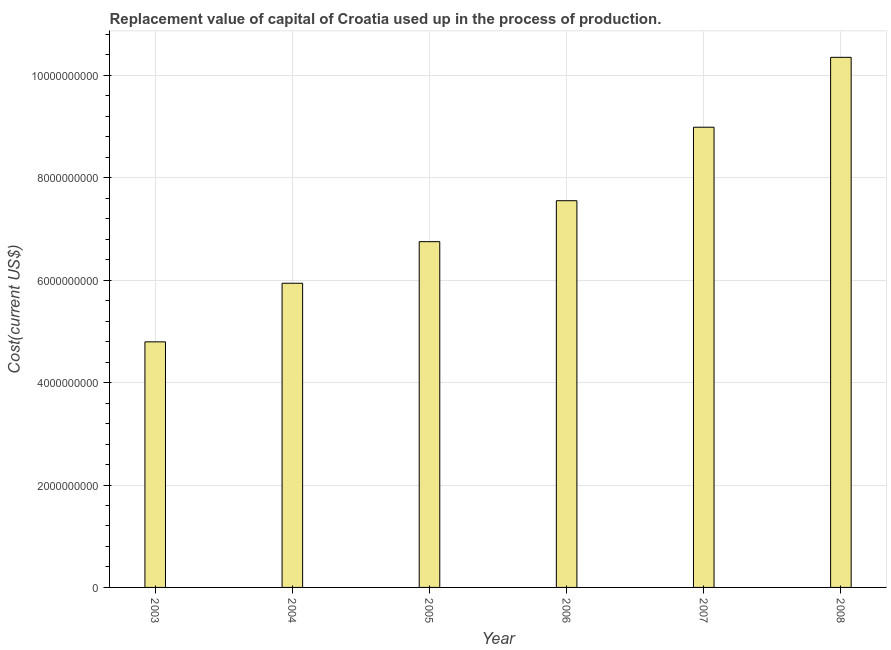Does the graph contain any zero values?
Make the answer very short. No. Does the graph contain grids?
Offer a terse response. Yes. What is the title of the graph?
Give a very brief answer. Replacement value of capital of Croatia used up in the process of production. What is the label or title of the X-axis?
Give a very brief answer. Year. What is the label or title of the Y-axis?
Offer a very short reply. Cost(current US$). What is the consumption of fixed capital in 2006?
Offer a terse response. 7.55e+09. Across all years, what is the maximum consumption of fixed capital?
Provide a succinct answer. 1.04e+1. Across all years, what is the minimum consumption of fixed capital?
Your answer should be very brief. 4.80e+09. In which year was the consumption of fixed capital maximum?
Give a very brief answer. 2008. In which year was the consumption of fixed capital minimum?
Provide a succinct answer. 2003. What is the sum of the consumption of fixed capital?
Give a very brief answer. 4.44e+1. What is the difference between the consumption of fixed capital in 2005 and 2008?
Provide a succinct answer. -3.60e+09. What is the average consumption of fixed capital per year?
Keep it short and to the point. 7.40e+09. What is the median consumption of fixed capital?
Provide a succinct answer. 7.15e+09. Do a majority of the years between 2006 and 2007 (inclusive) have consumption of fixed capital greater than 7200000000 US$?
Offer a terse response. Yes. What is the ratio of the consumption of fixed capital in 2007 to that in 2008?
Give a very brief answer. 0.87. Is the consumption of fixed capital in 2005 less than that in 2008?
Offer a terse response. Yes. Is the difference between the consumption of fixed capital in 2005 and 2007 greater than the difference between any two years?
Offer a terse response. No. What is the difference between the highest and the second highest consumption of fixed capital?
Offer a terse response. 1.37e+09. Is the sum of the consumption of fixed capital in 2006 and 2008 greater than the maximum consumption of fixed capital across all years?
Offer a terse response. Yes. What is the difference between the highest and the lowest consumption of fixed capital?
Your answer should be very brief. 5.56e+09. In how many years, is the consumption of fixed capital greater than the average consumption of fixed capital taken over all years?
Provide a short and direct response. 3. How many bars are there?
Keep it short and to the point. 6. Are all the bars in the graph horizontal?
Ensure brevity in your answer.  No. How many years are there in the graph?
Provide a short and direct response. 6. Are the values on the major ticks of Y-axis written in scientific E-notation?
Provide a short and direct response. No. What is the Cost(current US$) in 2003?
Give a very brief answer. 4.80e+09. What is the Cost(current US$) of 2004?
Offer a very short reply. 5.94e+09. What is the Cost(current US$) in 2005?
Offer a terse response. 6.75e+09. What is the Cost(current US$) in 2006?
Your response must be concise. 7.55e+09. What is the Cost(current US$) in 2007?
Offer a terse response. 8.99e+09. What is the Cost(current US$) in 2008?
Keep it short and to the point. 1.04e+1. What is the difference between the Cost(current US$) in 2003 and 2004?
Your answer should be compact. -1.14e+09. What is the difference between the Cost(current US$) in 2003 and 2005?
Your answer should be very brief. -1.96e+09. What is the difference between the Cost(current US$) in 2003 and 2006?
Provide a succinct answer. -2.76e+09. What is the difference between the Cost(current US$) in 2003 and 2007?
Your response must be concise. -4.19e+09. What is the difference between the Cost(current US$) in 2003 and 2008?
Provide a short and direct response. -5.56e+09. What is the difference between the Cost(current US$) in 2004 and 2005?
Make the answer very short. -8.12e+08. What is the difference between the Cost(current US$) in 2004 and 2006?
Your answer should be very brief. -1.61e+09. What is the difference between the Cost(current US$) in 2004 and 2007?
Make the answer very short. -3.05e+09. What is the difference between the Cost(current US$) in 2004 and 2008?
Your answer should be compact. -4.41e+09. What is the difference between the Cost(current US$) in 2005 and 2006?
Your response must be concise. -8.00e+08. What is the difference between the Cost(current US$) in 2005 and 2007?
Make the answer very short. -2.23e+09. What is the difference between the Cost(current US$) in 2005 and 2008?
Provide a succinct answer. -3.60e+09. What is the difference between the Cost(current US$) in 2006 and 2007?
Give a very brief answer. -1.43e+09. What is the difference between the Cost(current US$) in 2006 and 2008?
Provide a short and direct response. -2.80e+09. What is the difference between the Cost(current US$) in 2007 and 2008?
Your answer should be compact. -1.37e+09. What is the ratio of the Cost(current US$) in 2003 to that in 2004?
Your response must be concise. 0.81. What is the ratio of the Cost(current US$) in 2003 to that in 2005?
Your answer should be very brief. 0.71. What is the ratio of the Cost(current US$) in 2003 to that in 2006?
Your response must be concise. 0.64. What is the ratio of the Cost(current US$) in 2003 to that in 2007?
Your answer should be compact. 0.53. What is the ratio of the Cost(current US$) in 2003 to that in 2008?
Your response must be concise. 0.46. What is the ratio of the Cost(current US$) in 2004 to that in 2005?
Provide a succinct answer. 0.88. What is the ratio of the Cost(current US$) in 2004 to that in 2006?
Make the answer very short. 0.79. What is the ratio of the Cost(current US$) in 2004 to that in 2007?
Offer a terse response. 0.66. What is the ratio of the Cost(current US$) in 2004 to that in 2008?
Your response must be concise. 0.57. What is the ratio of the Cost(current US$) in 2005 to that in 2006?
Make the answer very short. 0.89. What is the ratio of the Cost(current US$) in 2005 to that in 2007?
Provide a succinct answer. 0.75. What is the ratio of the Cost(current US$) in 2005 to that in 2008?
Your answer should be very brief. 0.65. What is the ratio of the Cost(current US$) in 2006 to that in 2007?
Offer a terse response. 0.84. What is the ratio of the Cost(current US$) in 2006 to that in 2008?
Make the answer very short. 0.73. What is the ratio of the Cost(current US$) in 2007 to that in 2008?
Offer a terse response. 0.87. 